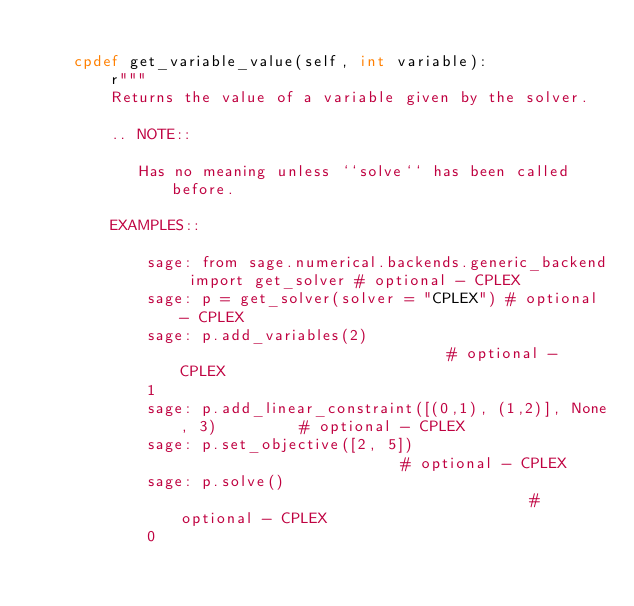<code> <loc_0><loc_0><loc_500><loc_500><_Cython_>
    cpdef get_variable_value(self, int variable):
        r"""
        Returns the value of a variable given by the solver.

        .. NOTE::

           Has no meaning unless ``solve`` has been called before.

        EXAMPLES::

            sage: from sage.numerical.backends.generic_backend import get_solver # optional - CPLEX
            sage: p = get_solver(solver = "CPLEX") # optional - CPLEX
            sage: p.add_variables(2)                              # optional - CPLEX
            1
            sage: p.add_linear_constraint([(0,1), (1,2)], None, 3)         # optional - CPLEX
            sage: p.set_objective([2, 5])                         # optional - CPLEX
            sage: p.solve()                                       # optional - CPLEX
            0</code> 